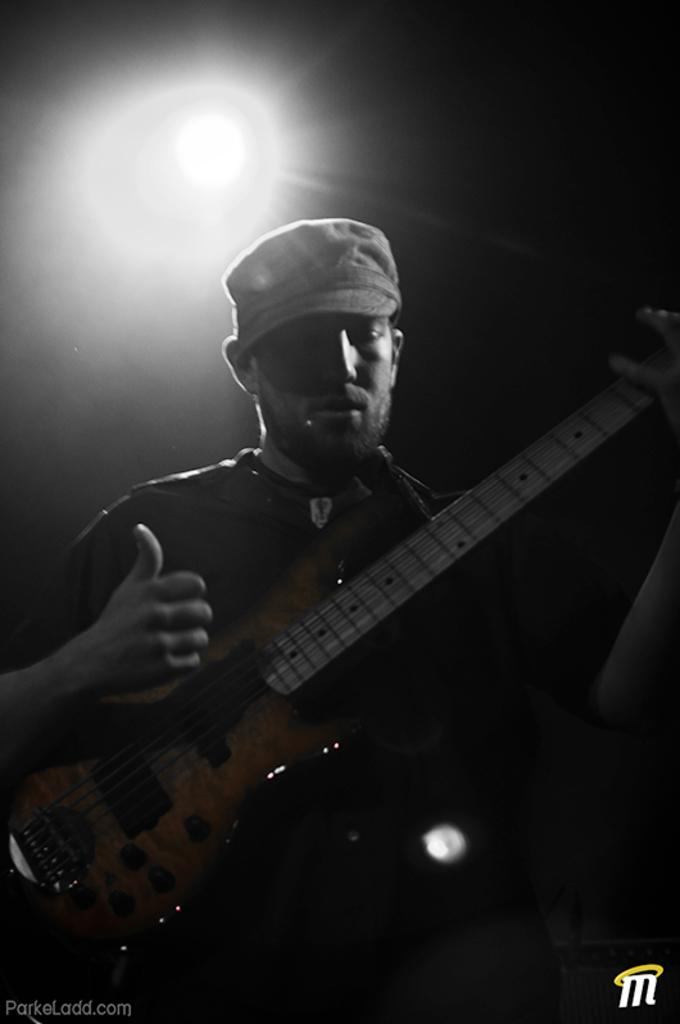What is the main subject of the image? There is a man in the image. What is the man holding in his hand? The man is holding a guitar in his hand. What type of pot is visible on the end of the guitar in the image? There is no pot visible on the guitar in the image. The guitar is a musical instrument and does not have a pot as part of its design. 